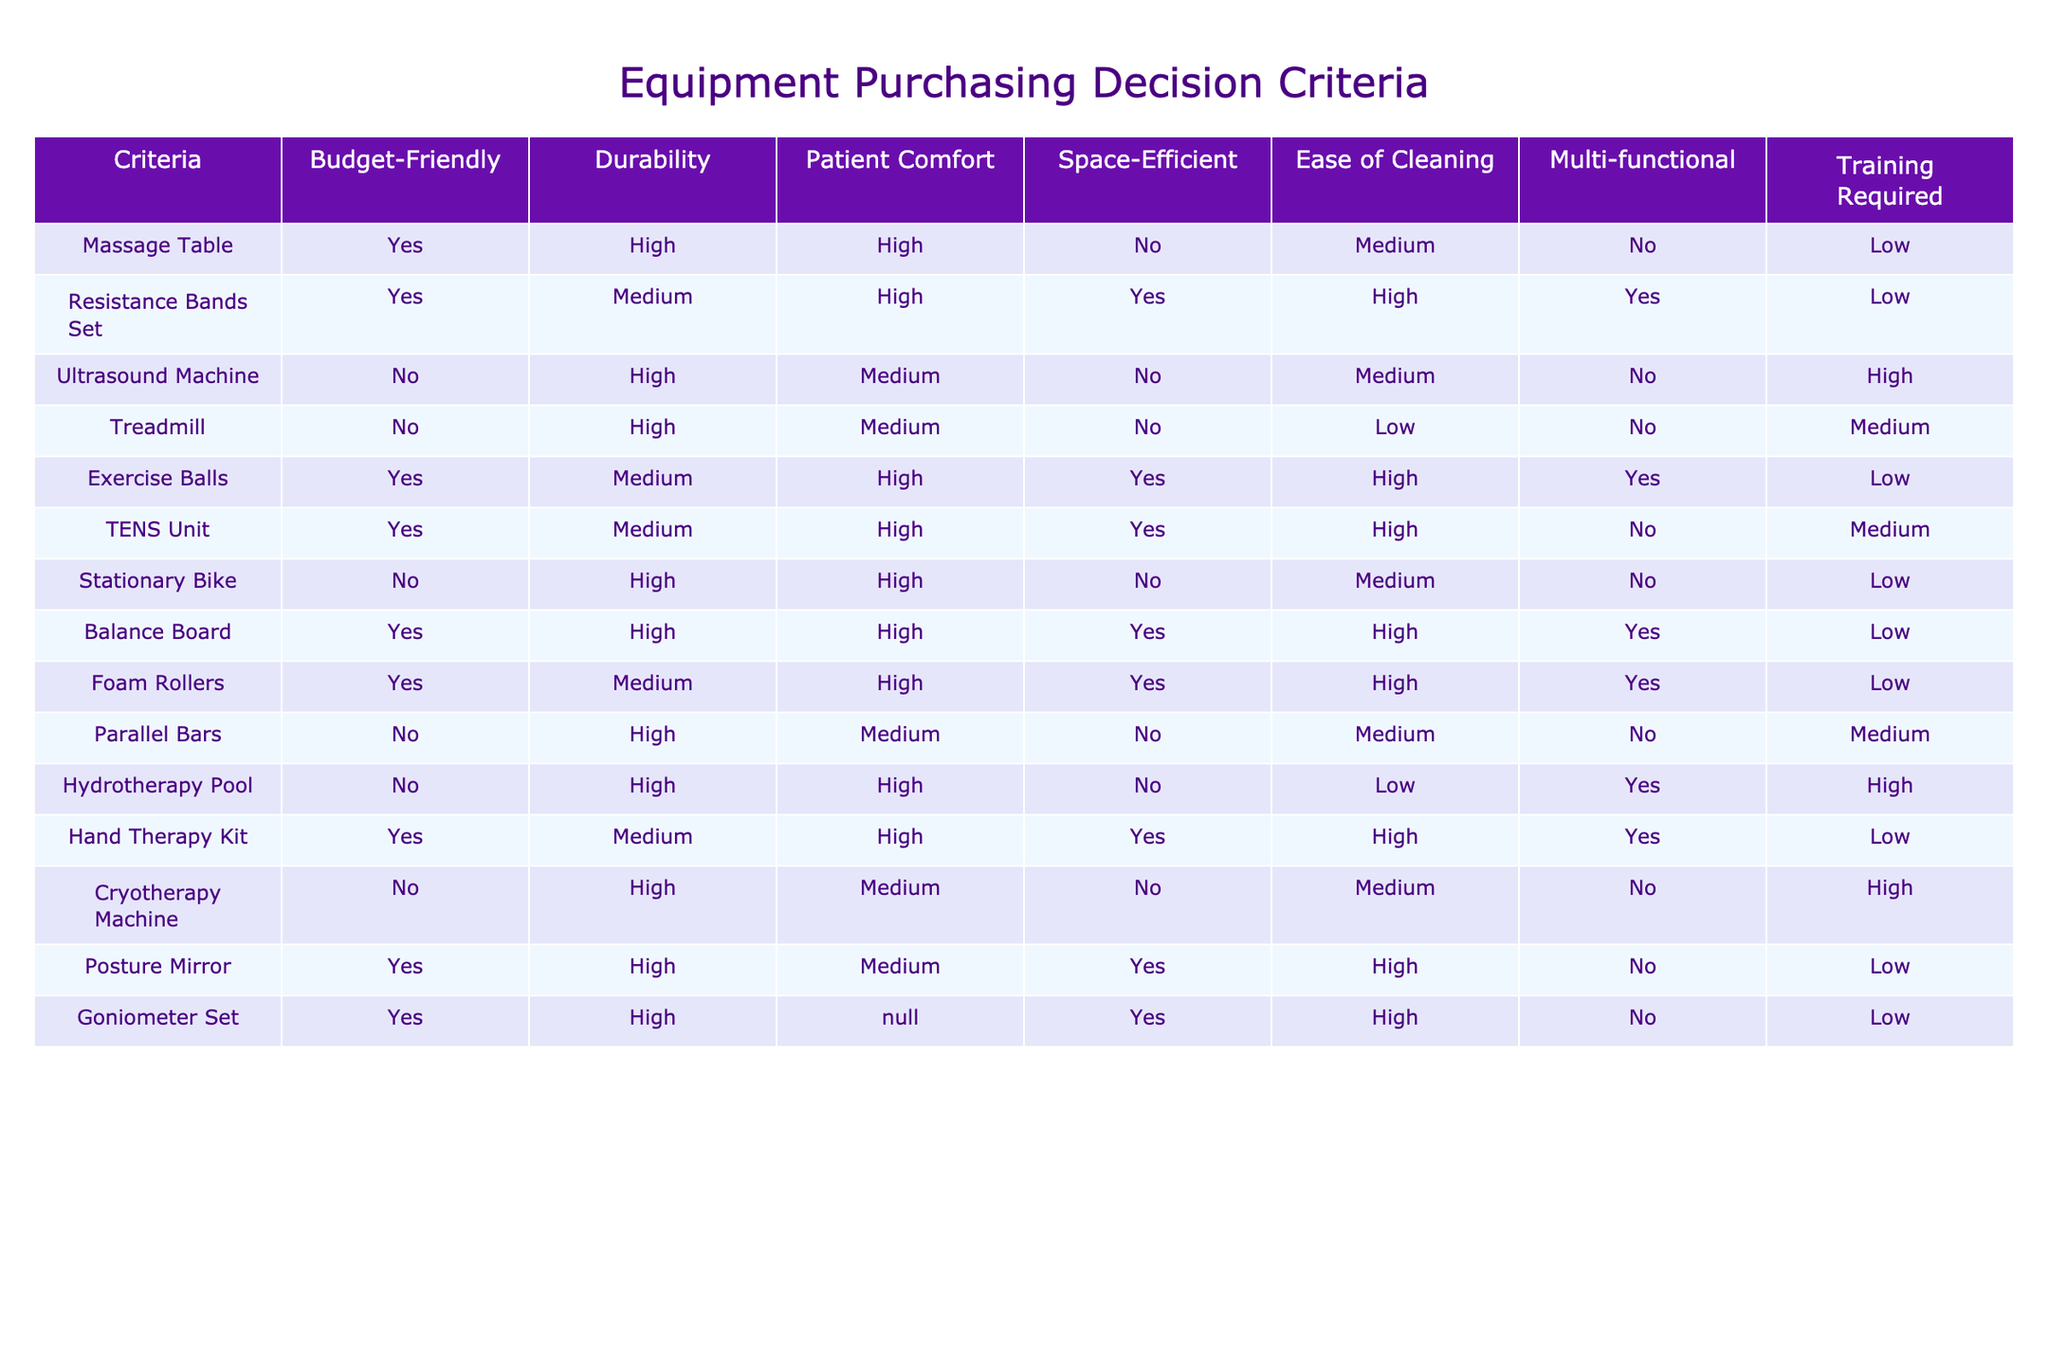What equipment is budget-friendly and requires low training? Looking at the table, we identify the two columns "Budget-Friendly" and "Training Required". We are looking for items that have "Yes" under "Budget-Friendly" and "Low" under "Training Required", which narrows it down to the Massage Table and Resistance Bands Set.
Answer: Massage Table, Resistance Bands Set Which equipment provides the highest patient comfort? We review the "Patient Comfort" column and identify the equipment with the highest rating, which is "High". The equipment that meets this criterion includes the Massage Table, Exercise Balls, TENS Unit, Stationary Bike, Balance Board, and Foam Rollers.
Answer: Massage Table, Exercise Balls, TENS Unit, Stationary Bike, Balance Board, Foam Rollers Is the Ultrasound Machine space-efficient? Referring to the table, we check the "Space-Efficient" column for the Ultrasound Machine, which states "No." Thus, it is not space-efficient.
Answer: No What is the total number of budget-friendly items available? By scanning the "Budget-Friendly" column, we count how many items are marked "Yes". There are 6 items identified: Massage Table, Resistance Bands Set, Exercise Balls, TENS Unit, Hand Therapy Kit, and Posture Mirror. Therefore, the total is 6.
Answer: 6 What percentage of items require high training? First, we identify the items in the "Training Required" column. The items with "High" under this category are the Ultrasound Machine, Treadmill, Parallel Bars, Hydrotherapy Pool, and Cryotherapy Machine, making a total of 5 out of 14 total items. To find the percentage: (5/14) * 100 ≈ 35.71%.
Answer: Approximately 35.71% Which equipment is both multi-functional and durable? We cross-reference the “Multi-functional” and “Durability” columns for equipment that has "Yes" and "High," respectively. The only item that meets both criteria is the Balance Board.
Answer: Balance Board How many items are both durable and patient-comfortable? To find this, we look at the "Durability" column for "High" and "Patient Comfort" column for "High" as well. We find the equipment that fits both: Massage Table, Exercise Balls, TENS Unit, Stationary Bike, Balance Board, and Foam Rollers, totaling 6.
Answer: 6 Do any items require no training? We check the "Training Required" column for items that state "Low." We identify the Massage Table, Resistance Bands Set, Exercise Balls, TENS Unit, Hand Therapy Kit, and Goniometer Set. Thus, there are items that require no training.
Answer: Yes 